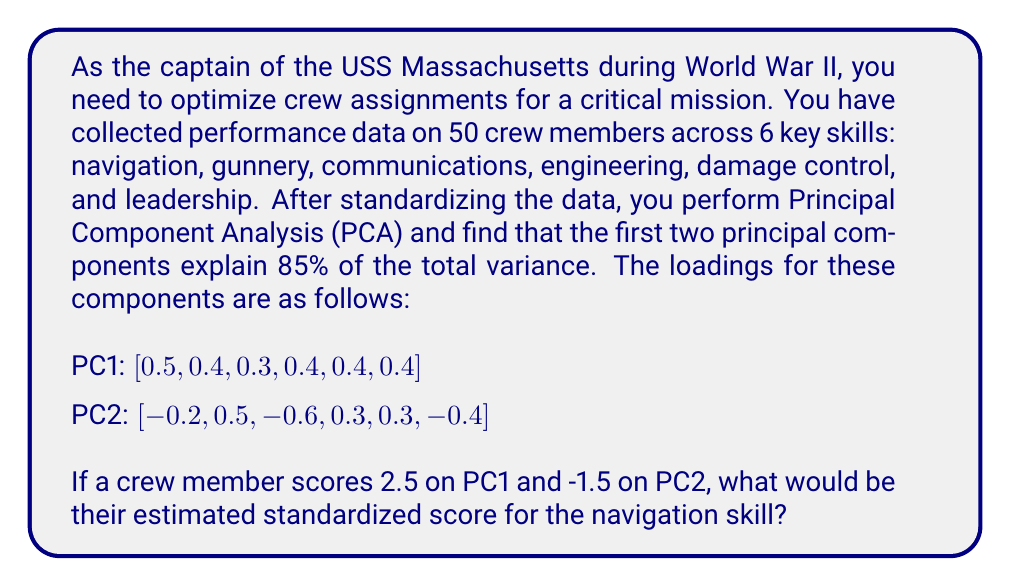Help me with this question. To solve this problem, we'll follow these steps:

1) Recall that in PCA, we can reconstruct the original variables using the principal components and their loadings. The general formula is:

   $$x_j \approx \sum_{i=1}^k l_{ji} \cdot PC_i$$

   where $x_j$ is the j-th original variable, $l_{ji}$ is the loading of the j-th variable on the i-th principal component, and $PC_i$ is the score on the i-th principal component.

2) In this case, we're only using the first two principal components, so our formula becomes:

   $$x_j \approx l_{j1} \cdot PC_1 + l_{j2} \cdot PC_2$$

3) We're interested in the navigation skill, which is the first variable. So we need:

   $$x_{navigation} \approx l_{11} \cdot PC_1 + l_{12} \cdot PC_2$$

4) From the given loadings:
   $l_{11} = 0.5$ (loading of navigation on PC1)
   $l_{12} = -0.2$ (loading of navigation on PC2)

5) We're also given the scores on PC1 and PC2:
   $PC_1 = 2.5$
   $PC_2 = -1.5$

6) Now we can plug these values into our equation:

   $$x_{navigation} \approx 0.5 \cdot 2.5 + (-0.2) \cdot (-1.5)$$

7) Let's calculate:
   $$x_{navigation} \approx 1.25 + 0.3 = 1.55$$

Therefore, the estimated standardized score for the navigation skill is approximately 1.55.
Answer: 1.55 